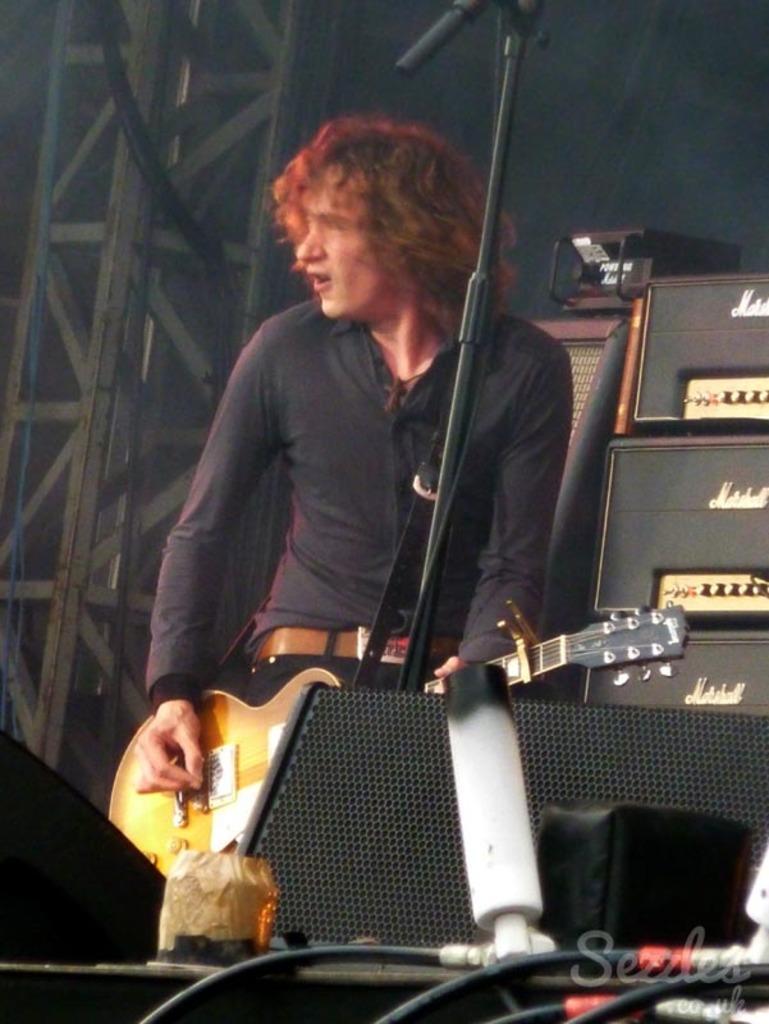In one or two sentences, can you explain what this image depicts? In this image I can see a person playing the musical instrument. To the side of him there is a sound system. In the front there are wires. 